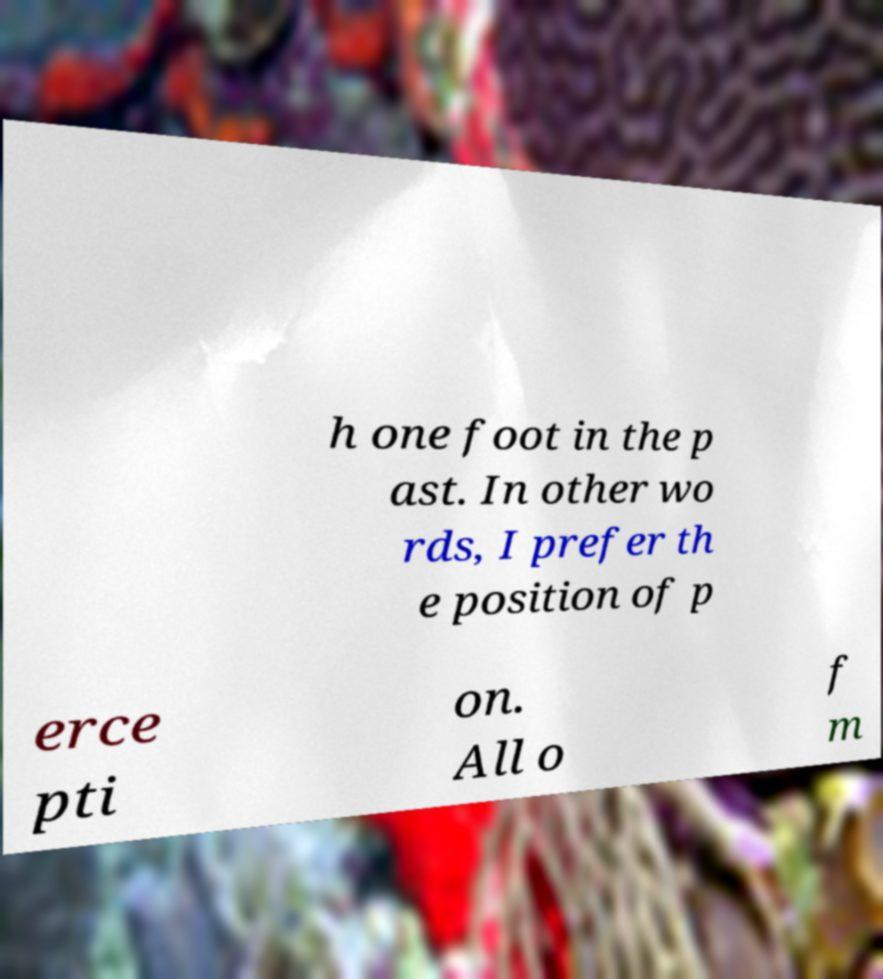Could you extract and type out the text from this image? h one foot in the p ast. In other wo rds, I prefer th e position of p erce pti on. All o f m 